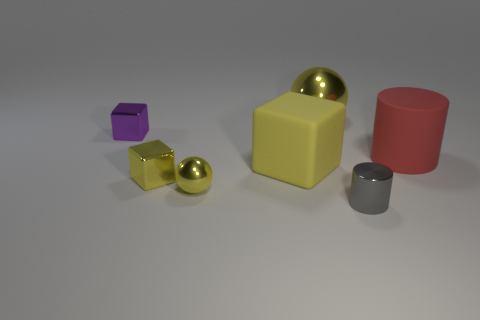Add 2 yellow shiny things. How many objects exist? 9 Subtract all spheres. How many objects are left? 5 Add 4 blocks. How many blocks exist? 7 Subtract 0 purple cylinders. How many objects are left? 7 Subtract all big yellow objects. Subtract all tiny cylinders. How many objects are left? 4 Add 7 balls. How many balls are left? 9 